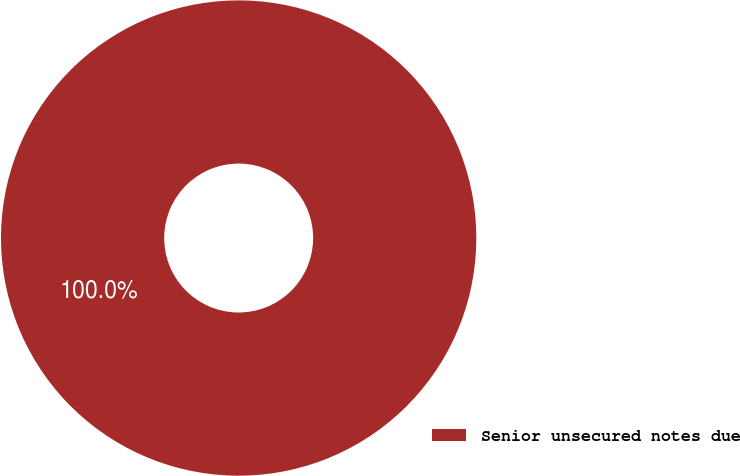Convert chart to OTSL. <chart><loc_0><loc_0><loc_500><loc_500><pie_chart><fcel>Senior unsecured notes due<nl><fcel>100.0%<nl></chart> 